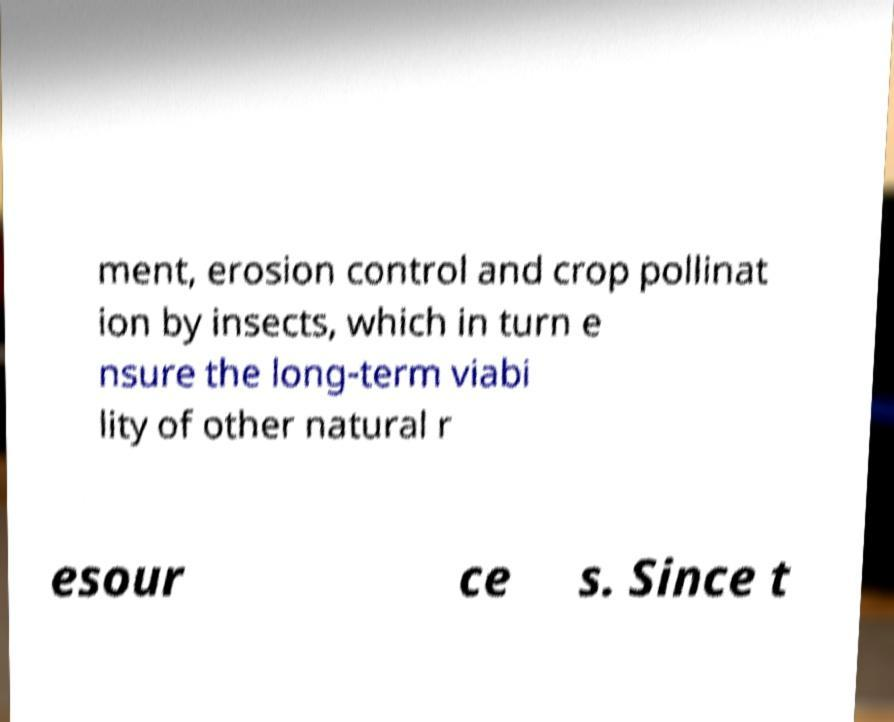Could you assist in decoding the text presented in this image and type it out clearly? ment, erosion control and crop pollinat ion by insects, which in turn e nsure the long-term viabi lity of other natural r esour ce s. Since t 